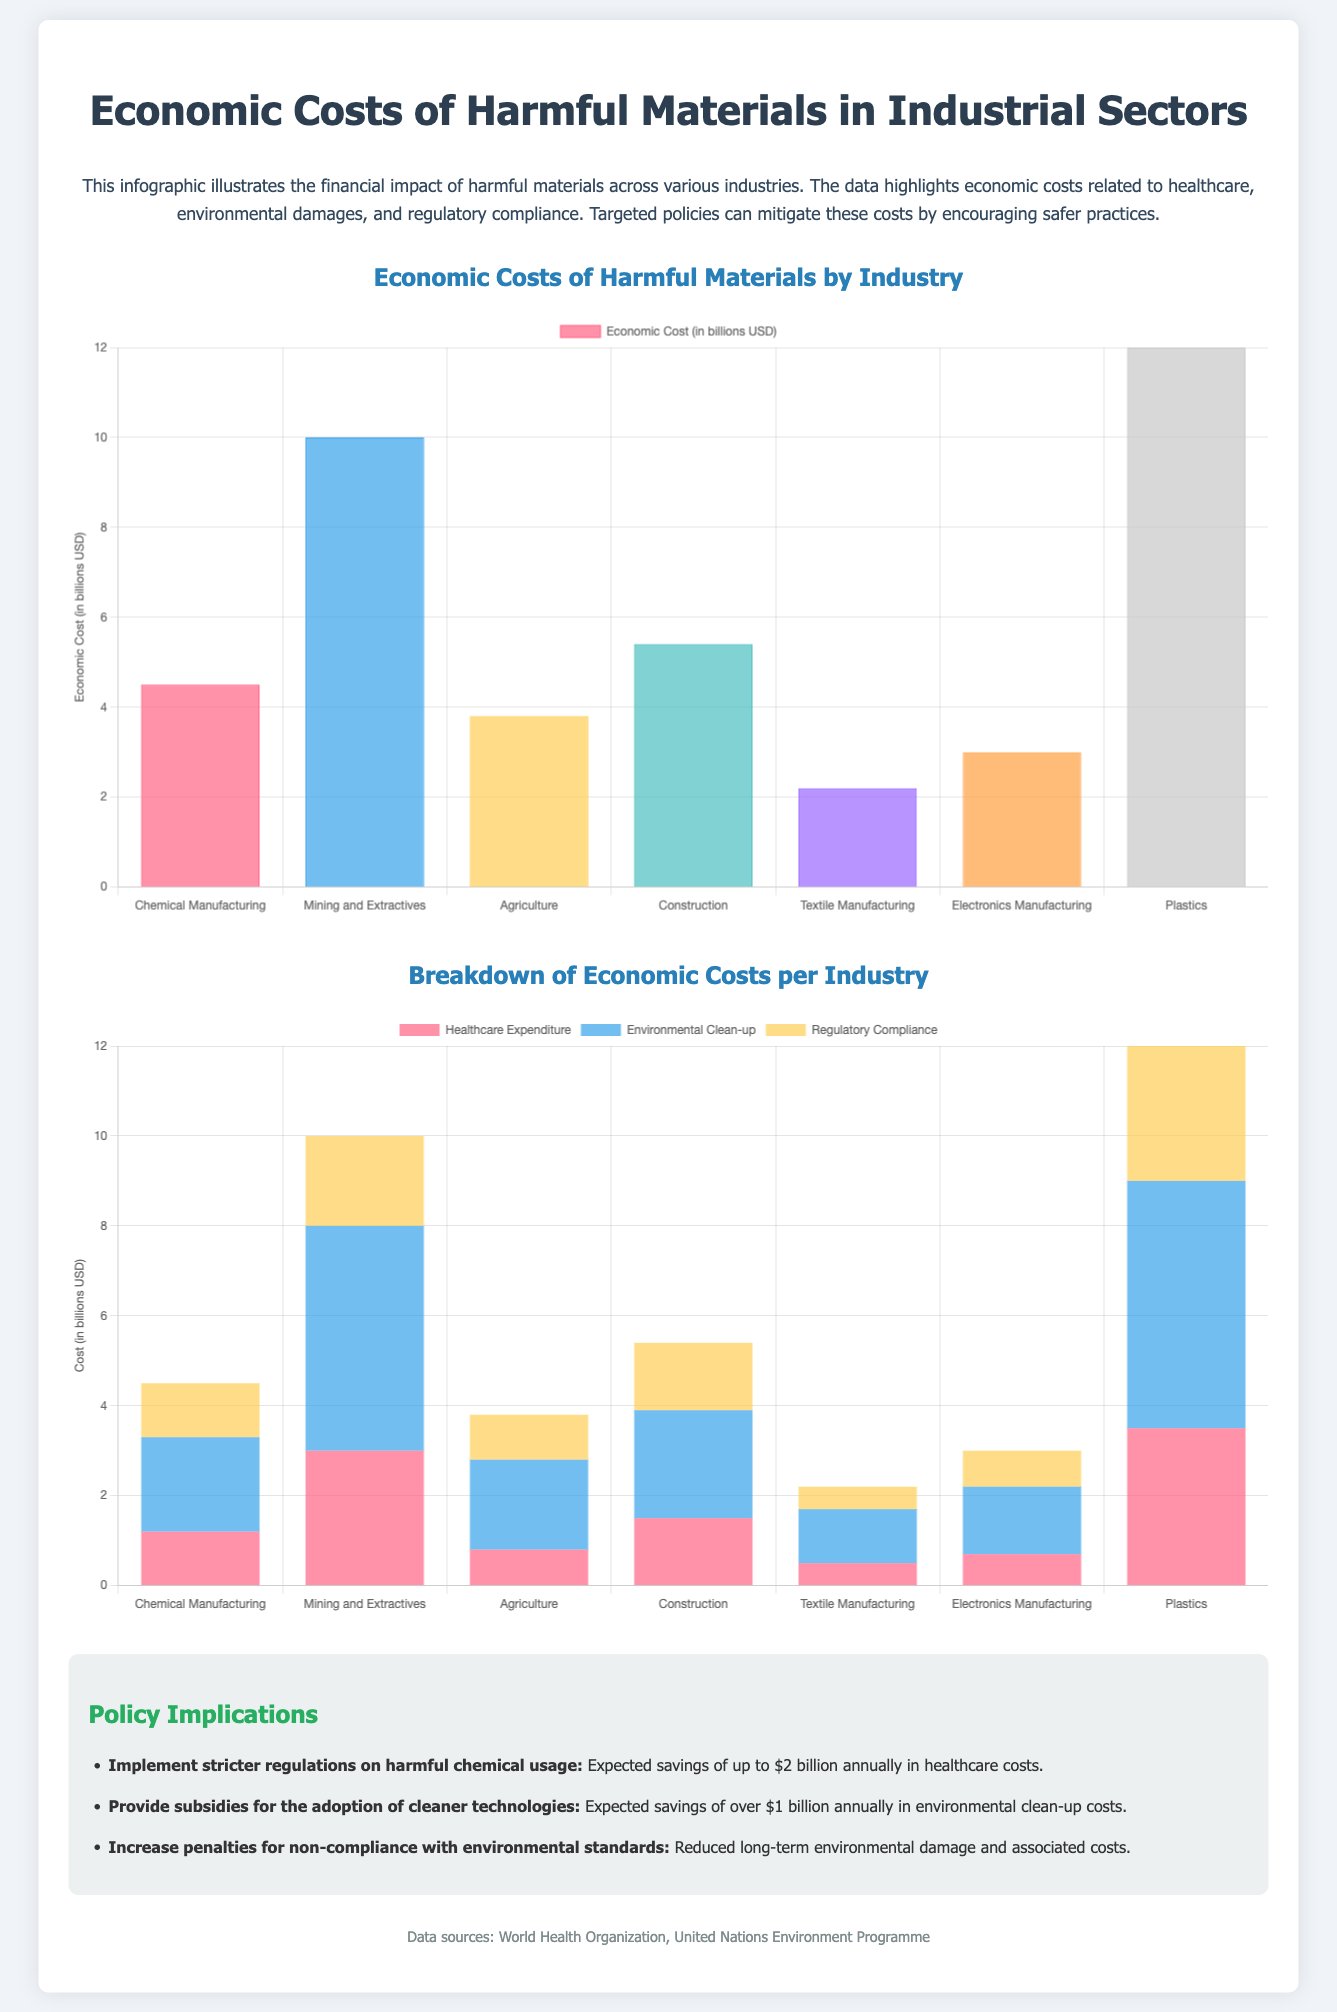What is the title of the infographic? The title is prominently displayed at the top of the document.
Answer: Economic Costs of Harmful Materials in Industrial Sectors Which industry has the highest economic cost? The bar graph shows the economic costs for each industry, highlighting the one with the highest value.
Answer: Plastics What is the economic cost for Agriculture? The bar chart provides specific numeric values for each industry, including Agriculture.
Answer: 3.8 billion USD What is the expected annual savings from stricter regulations? The policy implications section outlines potential savings from various initiatives.
Answer: 2 billion What are the three categories depicted in the stacked bar chart? The stacked bar chart lists specific categories that are broken down per industry.
Answer: Healthcare Expenditure, Environmental Clean-up, Regulatory Compliance How much is allocated for Environmental Clean-up in Textile Manufacturing? The stacked bar chart displays costs for each industry and category, including Textile Manufacturing.
Answer: 1.2 billion USD What is the color used for Regulatory Compliance in the stacked chart? Each dataset in the stacked chart has a distinct color, which can be identified visually.
Answer: Yellow What is the total economic cost for Mining and Extractives? The bar chart provides a specific figure for each industry, including Mining and Extractives.
Answer: 10 billion USD 